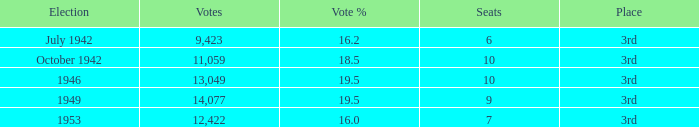Name the most vote % with election of 1946 19.5. 